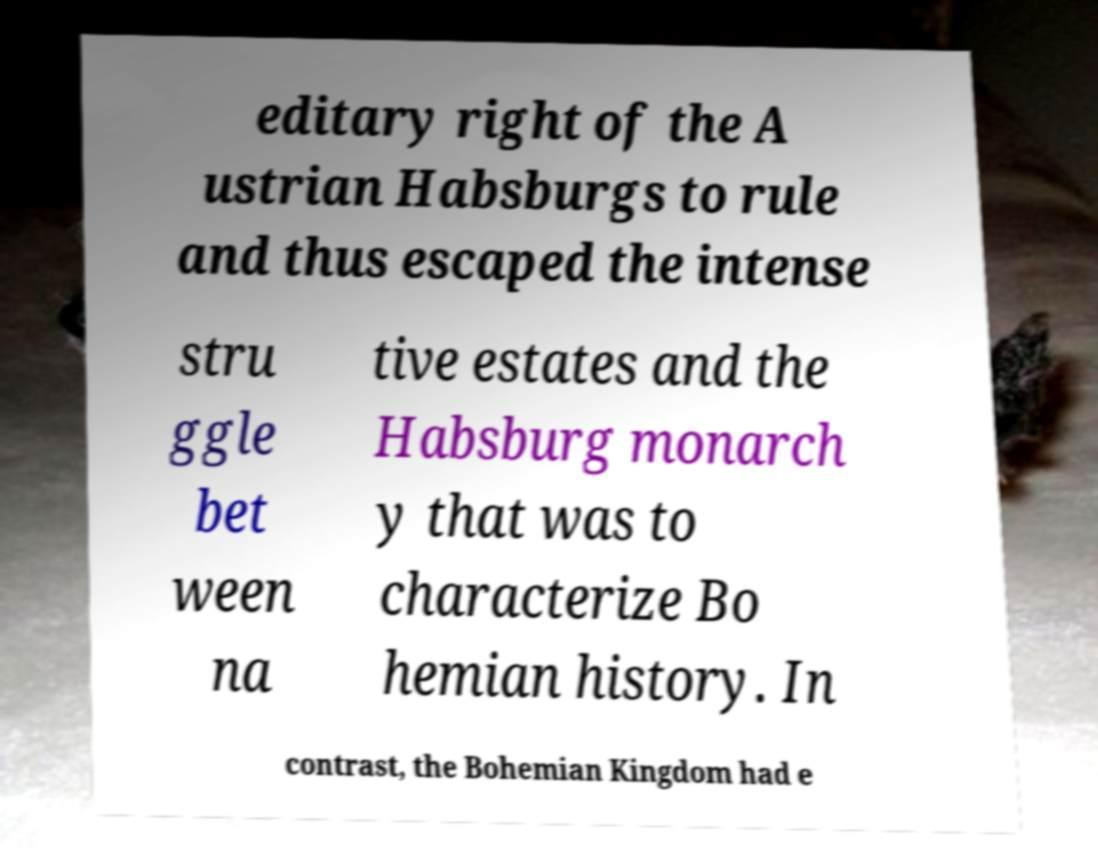Could you extract and type out the text from this image? editary right of the A ustrian Habsburgs to rule and thus escaped the intense stru ggle bet ween na tive estates and the Habsburg monarch y that was to characterize Bo hemian history. In contrast, the Bohemian Kingdom had e 